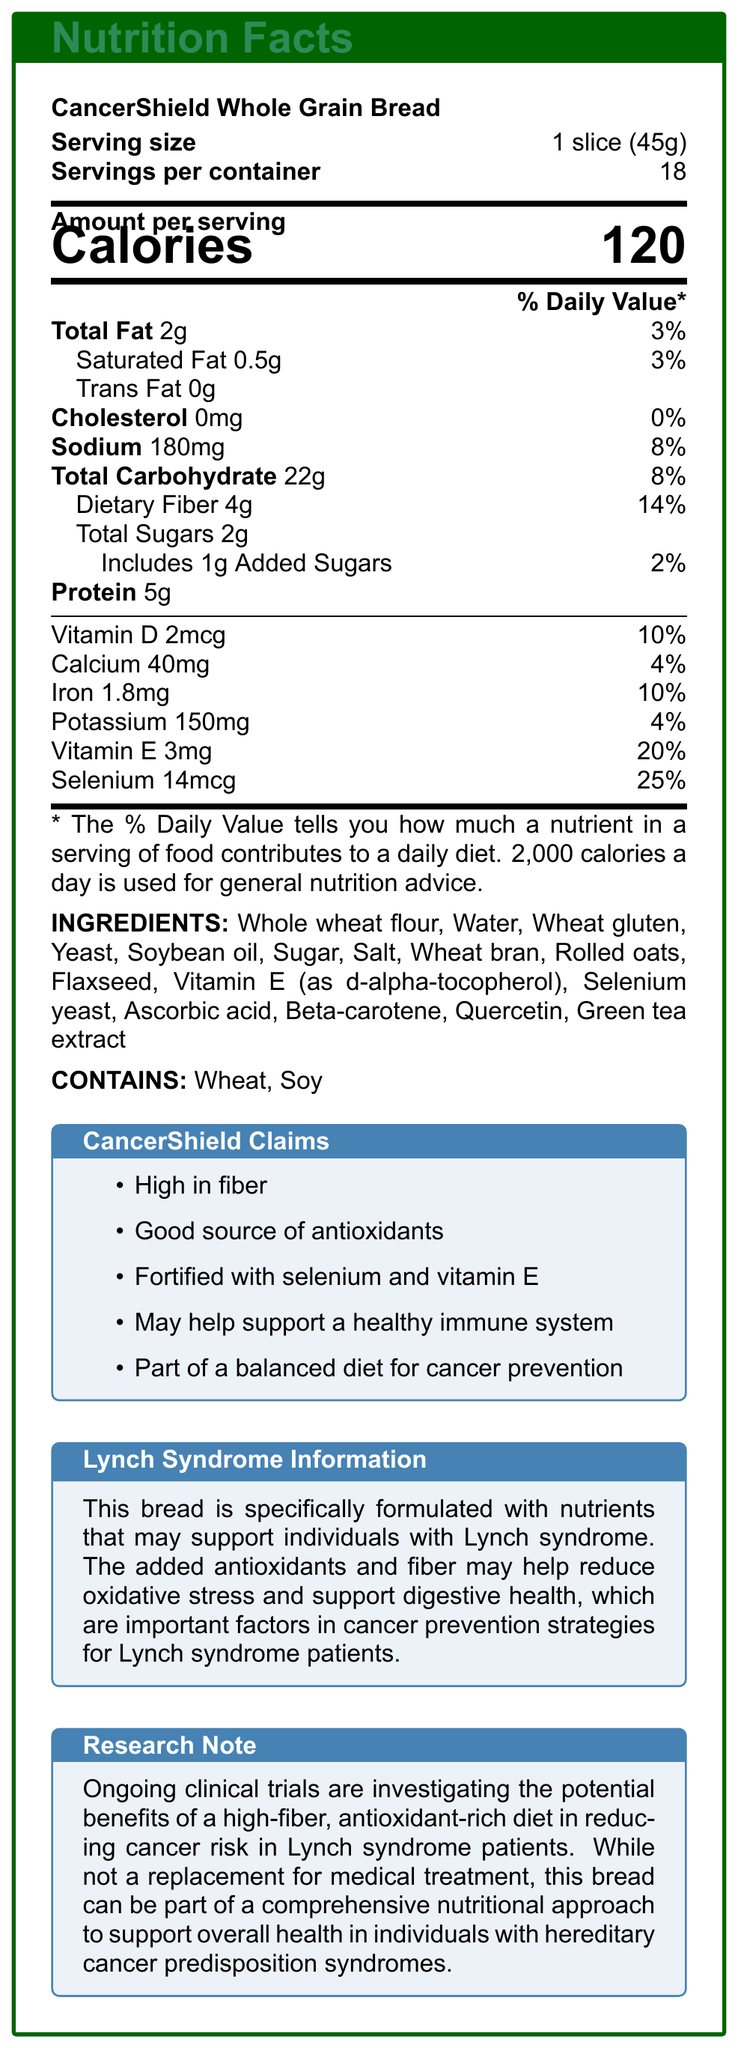what is the serving size? The document lists the serving size as 1 slice, which weighs 45 grams.
Answer: 1 slice (45g) how many calories are in one serving? In the "Amount per serving" section, it states that there are 120 calories per serving.
Answer: 120 what is the amount of dietary fiber per serving? The section detailing nutrients lists 4 grams of dietary fiber per serving.
Answer: 4g does this bread contain any trans fats? The document indicates that the bread contains 0g of trans fats.
Answer: No what allergens are contained in this bread? The "Contains" section specifies that the bread contains wheat and soy.
Answer: Wheat, Soy how much selenium is in one serving? The nutrient information section lists 14mcg of selenium per serving.
Answer: 14mcg what is the percentage of the daily value for iron per serving? The document states that each serving provides 10% of the daily value for iron.
Answer: 10% what kind of flour is used in this bread? The ingredient list starts with whole wheat flour, indicating it is the primary type of flour used.
Answer: Whole wheat flour which vitamins and minerals are specifically highlighted for their content in this bread? A. Vitamin A and C B. Vitamin D and Calcium C. Vitamin E and Selenium The document mentions both Vitamin E and Selenium prominently in the claims section and nutrition information.
Answer: C how much sodium is in one serving? A. 120mg B. 150mg C. 180mg D. 200mg The nutrient section states that one serving contains 180mg of sodium.
Answer: C is this bread high in fiber? The "CancerShield Claims" and nutrient information sections both highlight that the bread is high in fiber, with each serving providing 4 grams of dietary fiber.
Answer: Yes does this bread contain any cholesterol? The document lists 0mg of cholesterol per serving.
Answer: No summarize the main idea of the document. The document serves to inform consumers about the nutrient profile and health benefits of CancerShield Whole Grain Bread, highlighting its potential to aid in cancer prevention as part of a balanced diet.
Answer: The document provides nutrition facts for CancerShield Whole Grain Bread, emphasizing its nutrient content designed to support cancer prevention, particularly for individuals with Lynch syndrome. It details the bread's high fiber and antioxidant content, along with specific nutrients like selenium and vitamin E. The bread includes whole wheat flour and other healthful ingredients while being free from trans fats and cholesterol. An allergen warning for wheat and soy is also provided. how much protein is in one slice of bread? The nutrient section states that there are 5 grams of protein per serving.
Answer: 5g what is the primary form of Vitamin E in this bread? The ingredient list specifies that Vitamin E is in the form of d-alpha-tocopherol.
Answer: d-alpha-tocopherol what clinical trials are mentioned in the document? The document mentions ongoing clinical trials but does not provide specific details about them.
Answer: Cannot be determined 